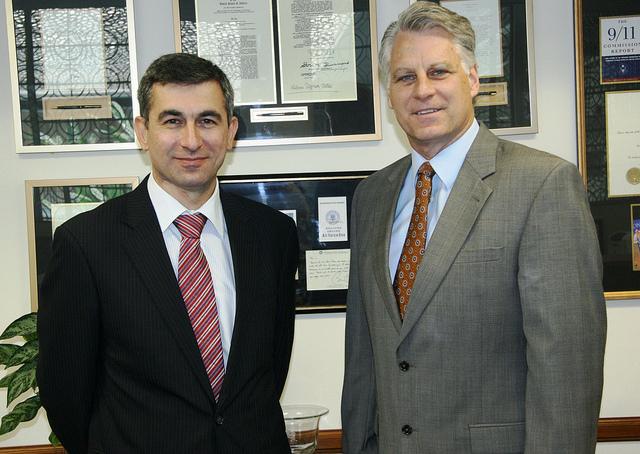Do there suits match?
Answer briefly. No. Who were these men?
Quick response, please. Businessmen. Do these men know each other?
Concise answer only. Yes. How many men are wearing ties?
Be succinct. 2. Where is the man in tie and suit?
Quick response, please. Office. 